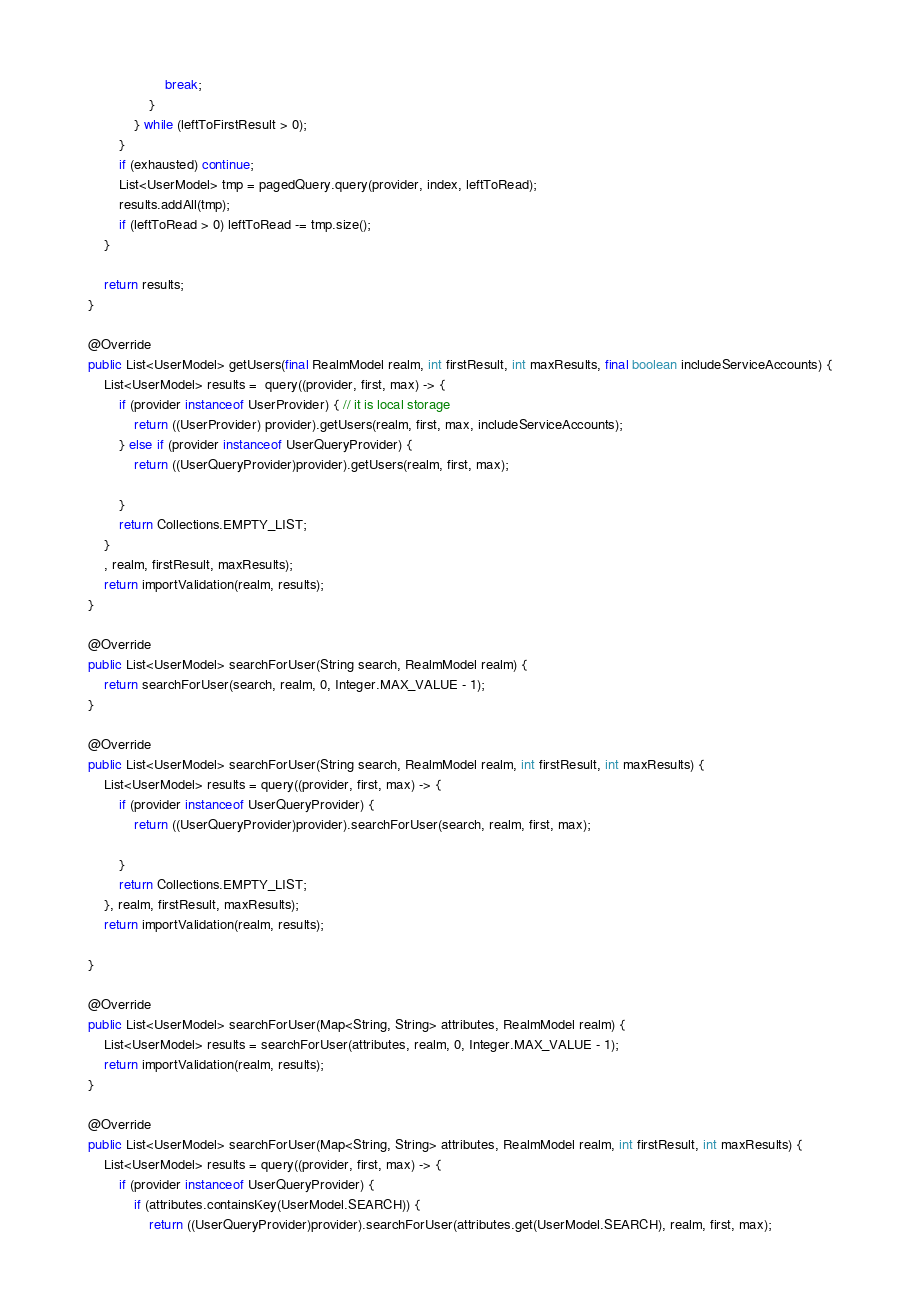<code> <loc_0><loc_0><loc_500><loc_500><_Java_>                        break;
                    }
                } while (leftToFirstResult > 0);
            }
            if (exhausted) continue;
            List<UserModel> tmp = pagedQuery.query(provider, index, leftToRead);
            results.addAll(tmp);
            if (leftToRead > 0) leftToRead -= tmp.size();
        }

        return results;
    }

    @Override
    public List<UserModel> getUsers(final RealmModel realm, int firstResult, int maxResults, final boolean includeServiceAccounts) {
        List<UserModel> results =  query((provider, first, max) -> {
            if (provider instanceof UserProvider) { // it is local storage
                return ((UserProvider) provider).getUsers(realm, first, max, includeServiceAccounts);
            } else if (provider instanceof UserQueryProvider) {
                return ((UserQueryProvider)provider).getUsers(realm, first, max);

            }
            return Collections.EMPTY_LIST;
        }
        , realm, firstResult, maxResults);
        return importValidation(realm, results);
    }

    @Override
    public List<UserModel> searchForUser(String search, RealmModel realm) {
        return searchForUser(search, realm, 0, Integer.MAX_VALUE - 1);
    }

    @Override
    public List<UserModel> searchForUser(String search, RealmModel realm, int firstResult, int maxResults) {
        List<UserModel> results = query((provider, first, max) -> {
            if (provider instanceof UserQueryProvider) {
                return ((UserQueryProvider)provider).searchForUser(search, realm, first, max);

            }
            return Collections.EMPTY_LIST;
        }, realm, firstResult, maxResults);
        return importValidation(realm, results);

    }

    @Override
    public List<UserModel> searchForUser(Map<String, String> attributes, RealmModel realm) {
        List<UserModel> results = searchForUser(attributes, realm, 0, Integer.MAX_VALUE - 1);
        return importValidation(realm, results);
    }

    @Override
    public List<UserModel> searchForUser(Map<String, String> attributes, RealmModel realm, int firstResult, int maxResults) {
        List<UserModel> results = query((provider, first, max) -> {
            if (provider instanceof UserQueryProvider) {
                if (attributes.containsKey(UserModel.SEARCH)) {
                    return ((UserQueryProvider)provider).searchForUser(attributes.get(UserModel.SEARCH), realm, first, max);</code> 